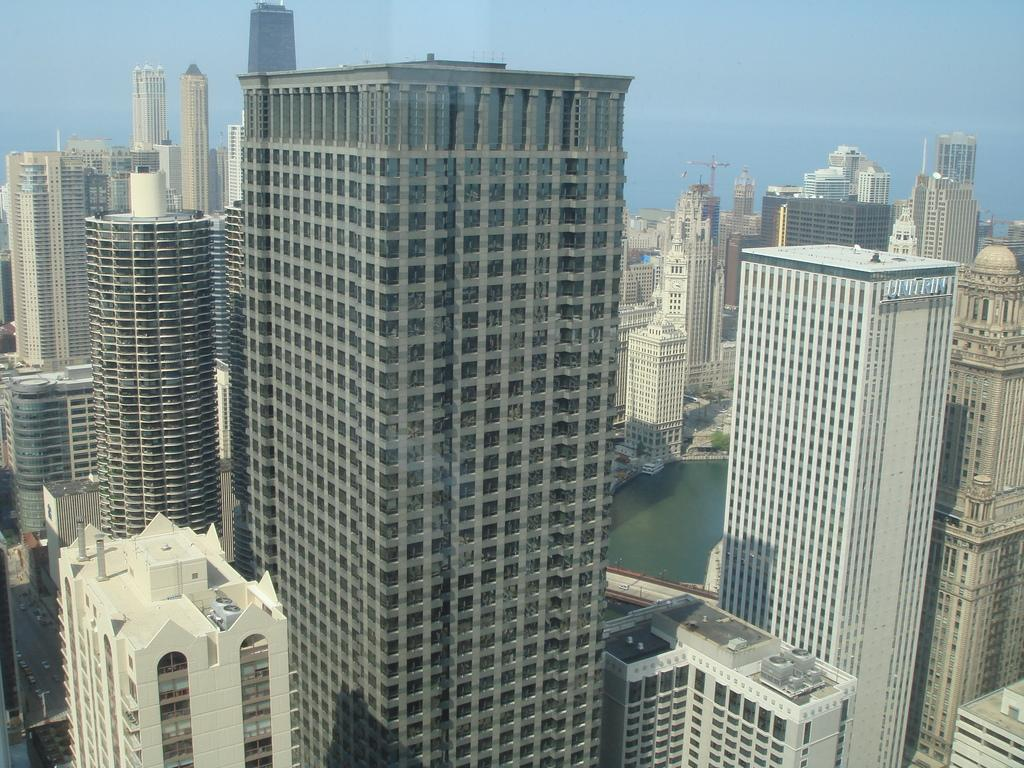What type of structures are present in the image? There are big buildings in the image. What natural element can be seen alongside the buildings? There is water visible in the image. What is visible at the top of the image? The sky is visible at the top of the image. How many trousers are hanging on the clothesline in the image? There is no clothesline or trousers present in the image. What is the amount of dirt visible in the image? There is no dirt visible in the image. 